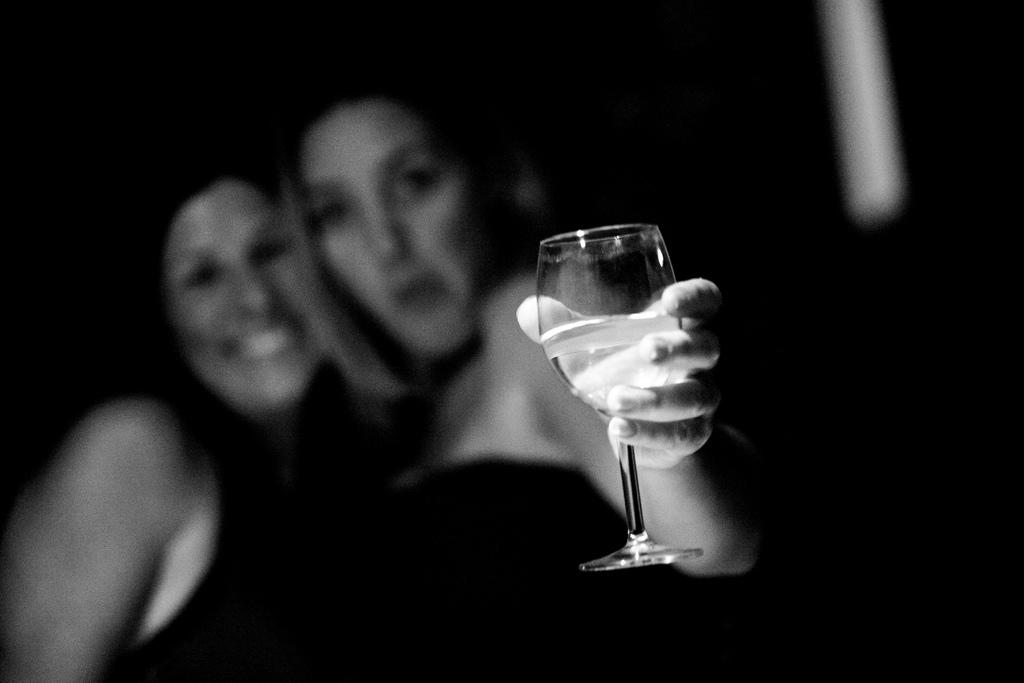How many people are present in the image? There are two people in the image. What is one person holding in the image? One person is holding a glass. What type of insurance policy is being discussed by the two people in the image? There is no indication in the image that the two people are discussing insurance policies. 